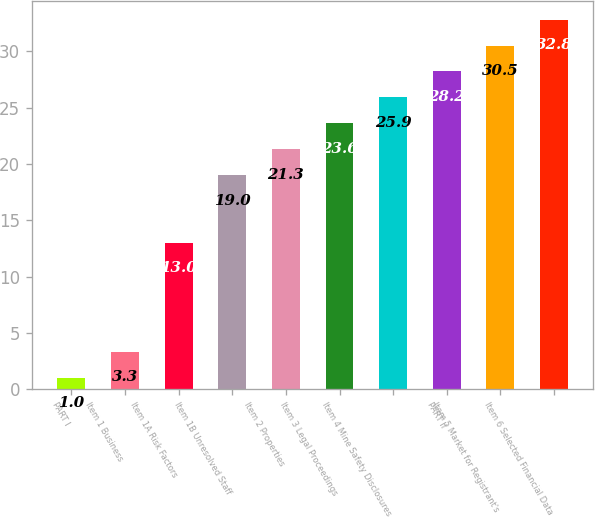Convert chart. <chart><loc_0><loc_0><loc_500><loc_500><bar_chart><fcel>PART I<fcel>Item 1 Business<fcel>Item 1A Risk Factors<fcel>Item 1B Unresolved Staff<fcel>Item 2 Properties<fcel>Item 3 Legal Proceedings<fcel>Item 4 Mine Safety Disclosures<fcel>PART II<fcel>Item 5 Market for Registrant's<fcel>Item 6 Selected Financial Data<nl><fcel>1<fcel>3.3<fcel>13<fcel>19<fcel>21.3<fcel>23.6<fcel>25.9<fcel>28.2<fcel>30.5<fcel>32.8<nl></chart> 